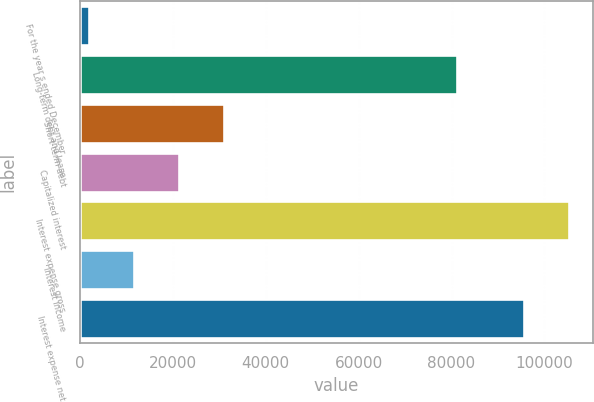<chart> <loc_0><loc_0><loc_500><loc_500><bar_chart><fcel>For the year s ended December<fcel>Long-term debt and lease<fcel>Short-term debt<fcel>Capitalized interest<fcel>Interest expense gross<fcel>Interest income<fcel>Interest expense net<nl><fcel>2012<fcel>81203<fcel>30961.1<fcel>21311.4<fcel>105219<fcel>11661.7<fcel>95569<nl></chart> 